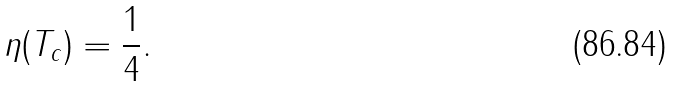<formula> <loc_0><loc_0><loc_500><loc_500>\eta ( T _ { c } ) = \frac { 1 } { 4 } .</formula> 